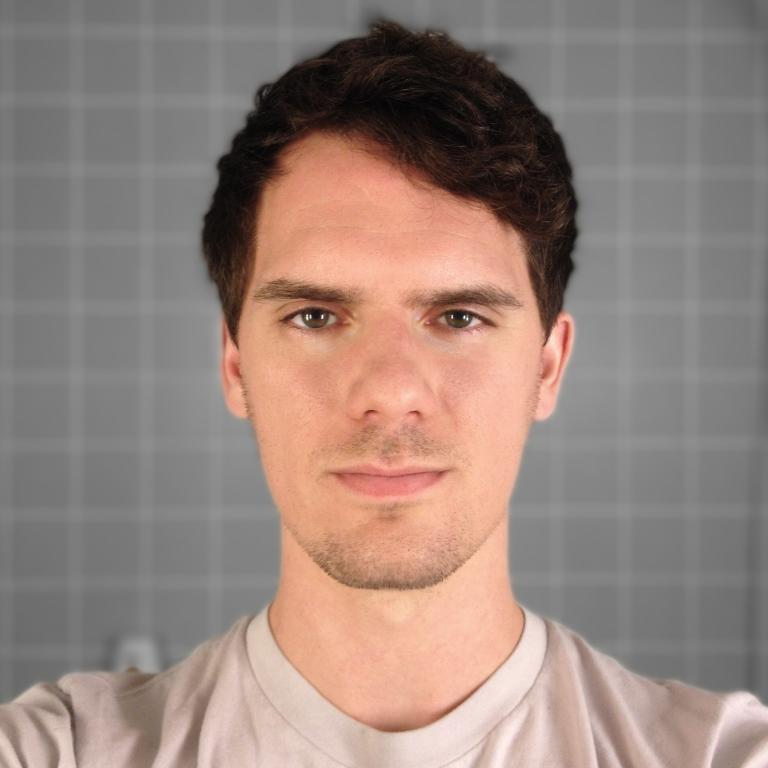Who or what is present in the image? There is a person in the image. What can be seen in the background of the image? There is a wall in the background of the image. What type of harmony can be heard in the image? There is no audible sound in the image, so it is not possible to determine if any harmony can be heard. 